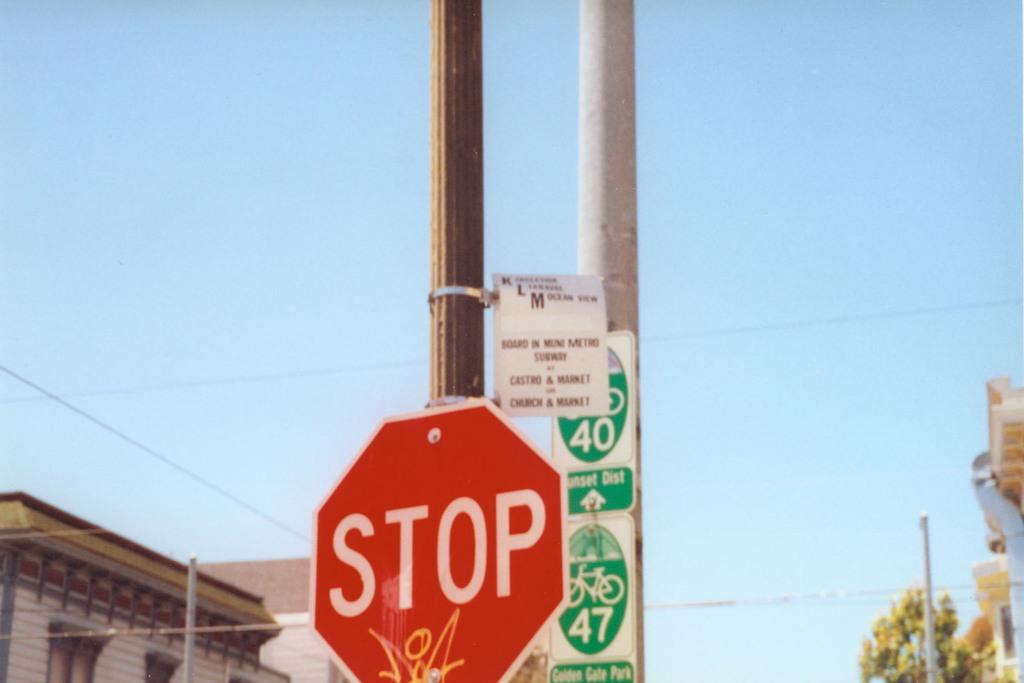<image>
Present a compact description of the photo's key features. The red sign sits infront of a green sign showing a bike and the number 47. 